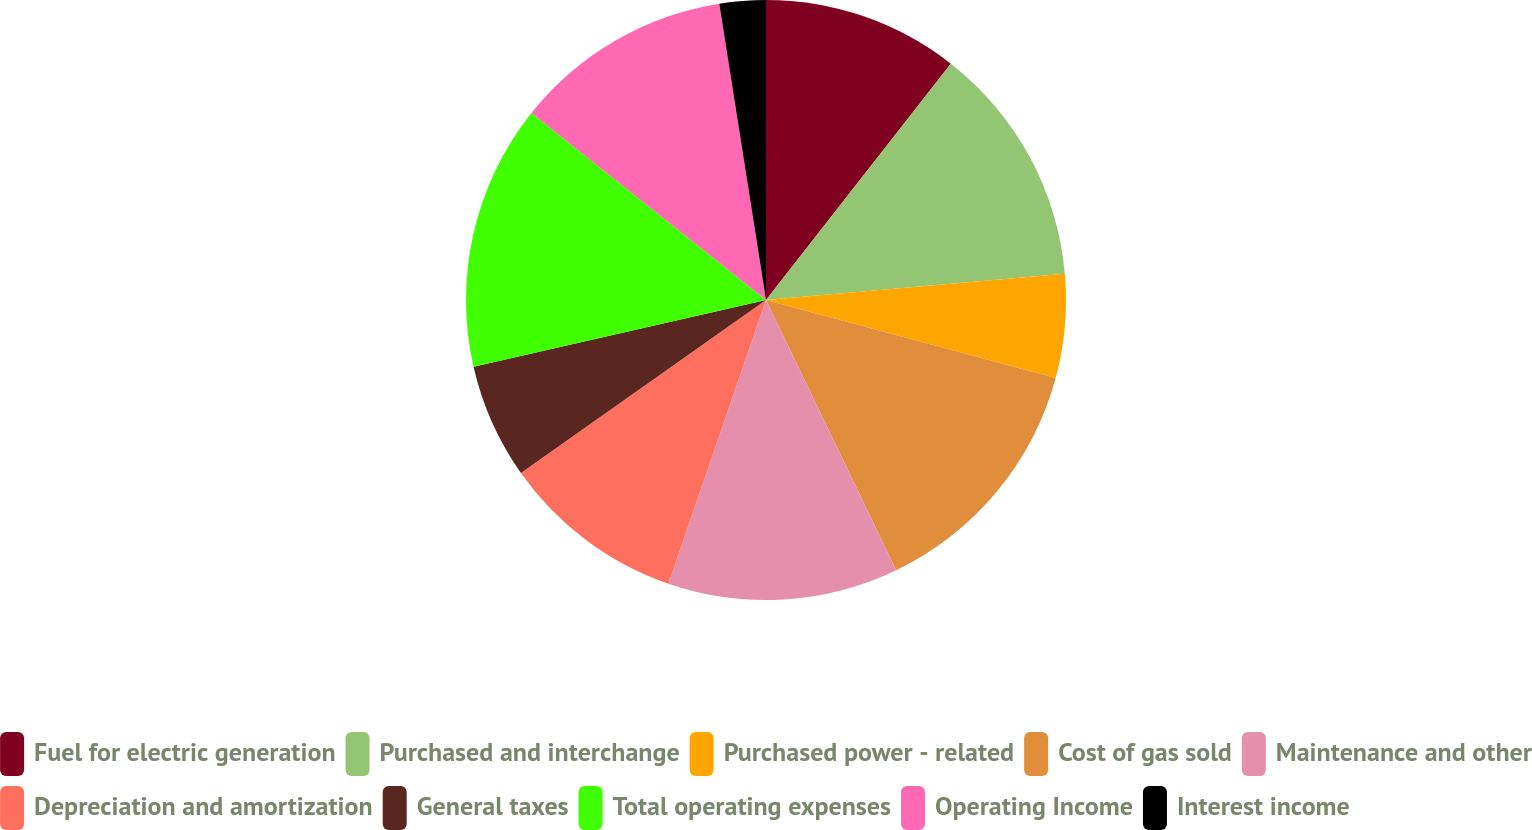Convert chart to OTSL. <chart><loc_0><loc_0><loc_500><loc_500><pie_chart><fcel>Fuel for electric generation<fcel>Purchased and interchange<fcel>Purchased power - related<fcel>Cost of gas sold<fcel>Maintenance and other<fcel>Depreciation and amortization<fcel>General taxes<fcel>Total operating expenses<fcel>Operating Income<fcel>Interest income<nl><fcel>10.56%<fcel>13.04%<fcel>5.59%<fcel>13.66%<fcel>12.42%<fcel>9.94%<fcel>6.21%<fcel>14.28%<fcel>11.8%<fcel>2.49%<nl></chart> 